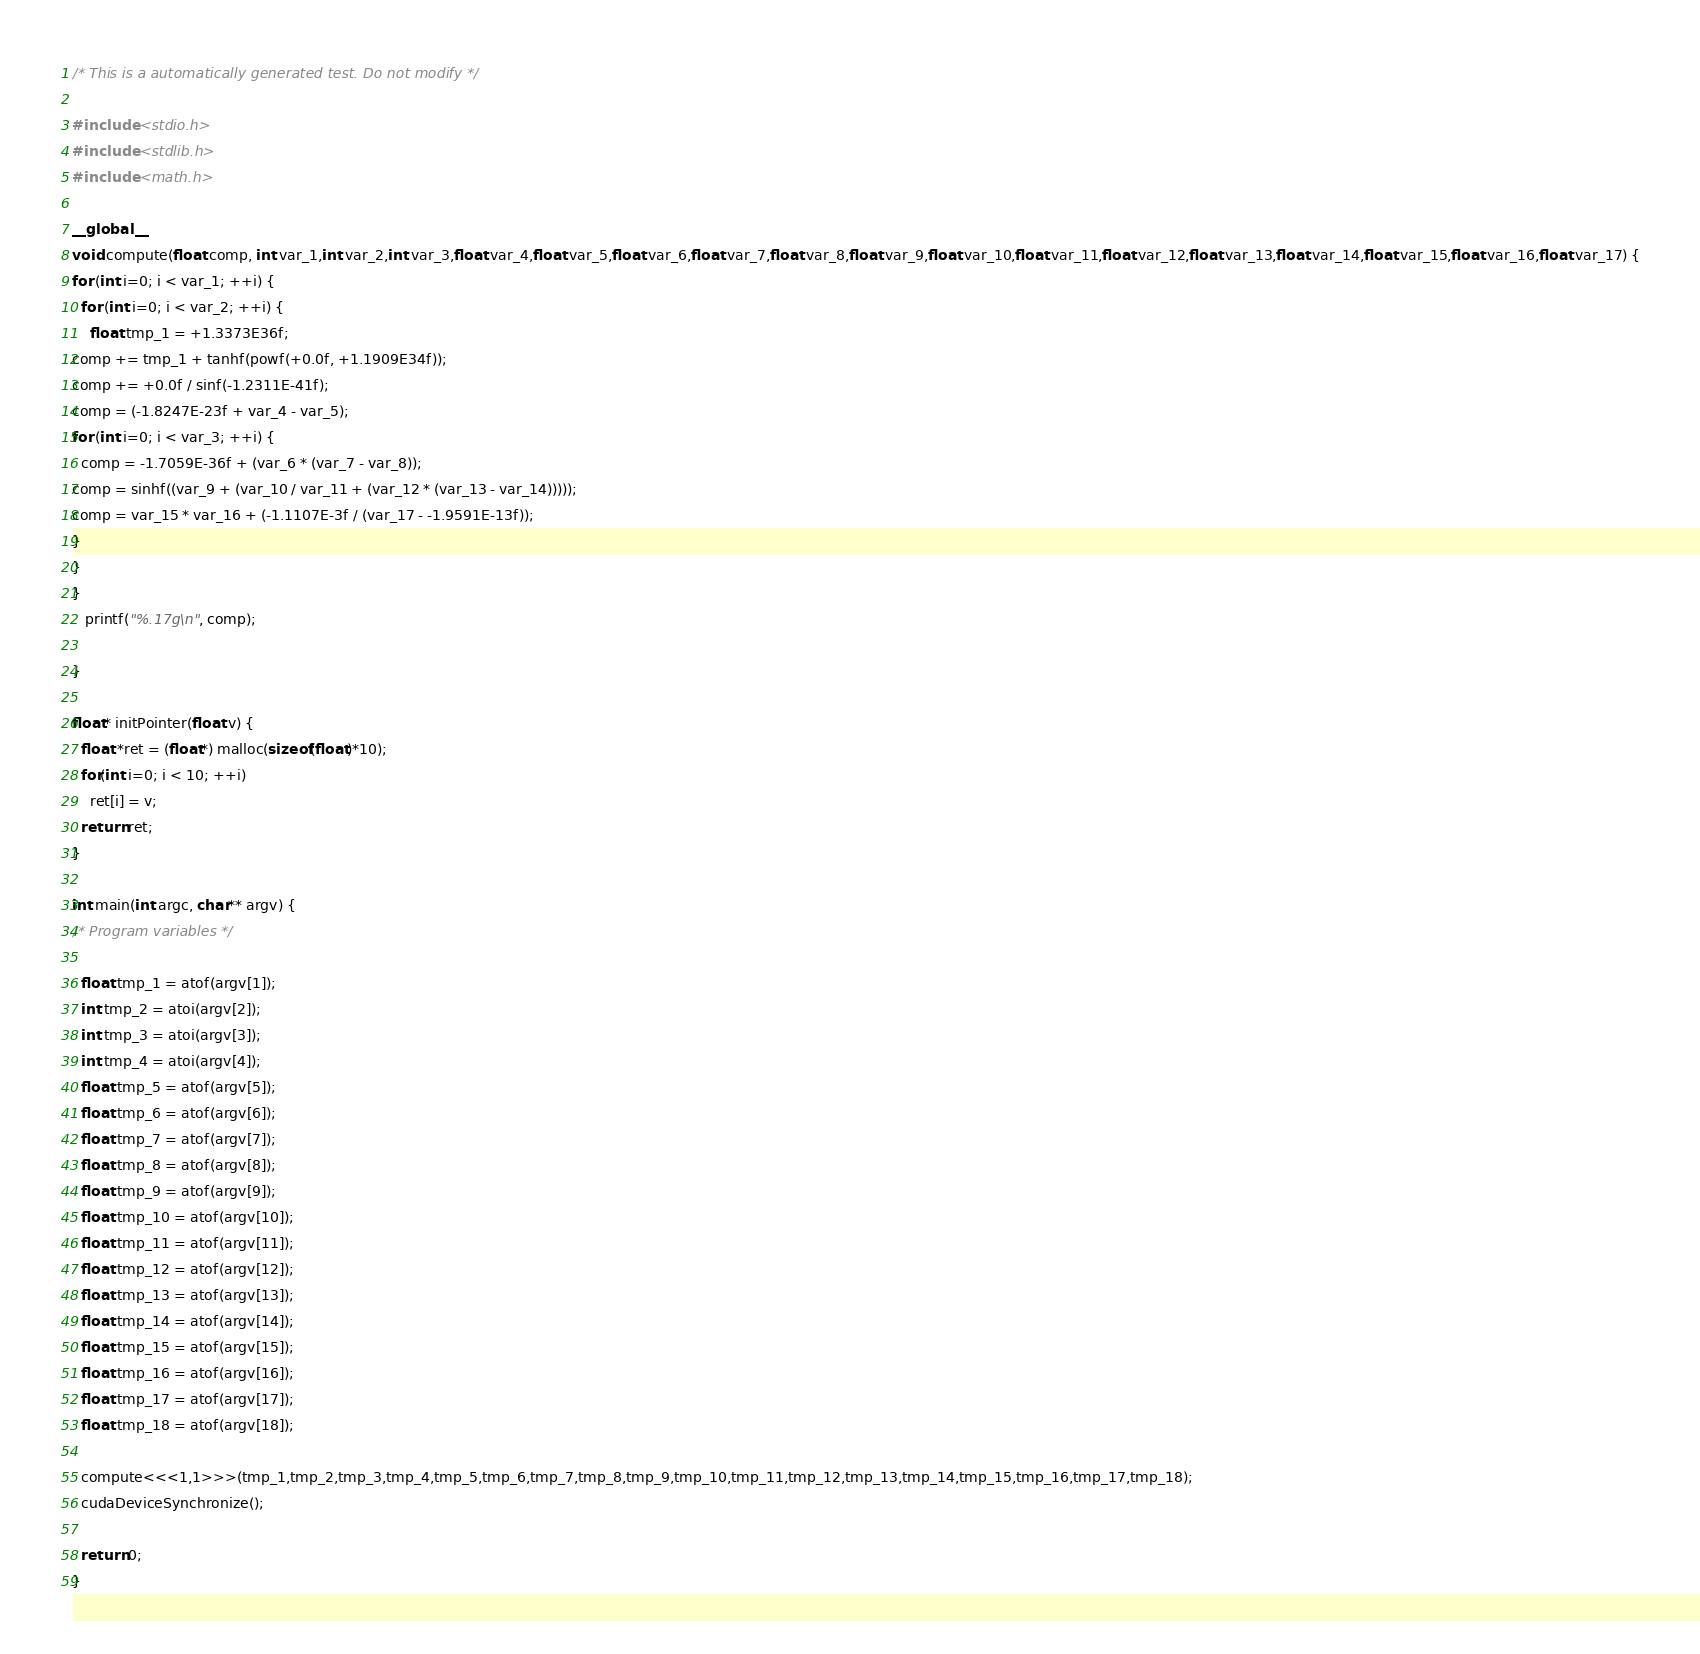<code> <loc_0><loc_0><loc_500><loc_500><_Cuda_>
/* This is a automatically generated test. Do not modify */

#include <stdio.h>
#include <stdlib.h>
#include <math.h>

__global__
void compute(float comp, int var_1,int var_2,int var_3,float var_4,float var_5,float var_6,float var_7,float var_8,float var_9,float var_10,float var_11,float var_12,float var_13,float var_14,float var_15,float var_16,float var_17) {
for (int i=0; i < var_1; ++i) {
  for (int i=0; i < var_2; ++i) {
    float tmp_1 = +1.3373E36f;
comp += tmp_1 + tanhf(powf(+0.0f, +1.1909E34f));
comp += +0.0f / sinf(-1.2311E-41f);
comp = (-1.8247E-23f + var_4 - var_5);
for (int i=0; i < var_3; ++i) {
  comp = -1.7059E-36f + (var_6 * (var_7 - var_8));
comp = sinhf((var_9 + (var_10 / var_11 + (var_12 * (var_13 - var_14)))));
comp = var_15 * var_16 + (-1.1107E-3f / (var_17 - -1.9591E-13f));
}
}
}
   printf("%.17g\n", comp);

}

float* initPointer(float v) {
  float *ret = (float*) malloc(sizeof(float)*10);
  for(int i=0; i < 10; ++i)
    ret[i] = v;
  return ret;
}

int main(int argc, char** argv) {
/* Program variables */

  float tmp_1 = atof(argv[1]);
  int tmp_2 = atoi(argv[2]);
  int tmp_3 = atoi(argv[3]);
  int tmp_4 = atoi(argv[4]);
  float tmp_5 = atof(argv[5]);
  float tmp_6 = atof(argv[6]);
  float tmp_7 = atof(argv[7]);
  float tmp_8 = atof(argv[8]);
  float tmp_9 = atof(argv[9]);
  float tmp_10 = atof(argv[10]);
  float tmp_11 = atof(argv[11]);
  float tmp_12 = atof(argv[12]);
  float tmp_13 = atof(argv[13]);
  float tmp_14 = atof(argv[14]);
  float tmp_15 = atof(argv[15]);
  float tmp_16 = atof(argv[16]);
  float tmp_17 = atof(argv[17]);
  float tmp_18 = atof(argv[18]);

  compute<<<1,1>>>(tmp_1,tmp_2,tmp_3,tmp_4,tmp_5,tmp_6,tmp_7,tmp_8,tmp_9,tmp_10,tmp_11,tmp_12,tmp_13,tmp_14,tmp_15,tmp_16,tmp_17,tmp_18);
  cudaDeviceSynchronize();

  return 0;
}
</code> 